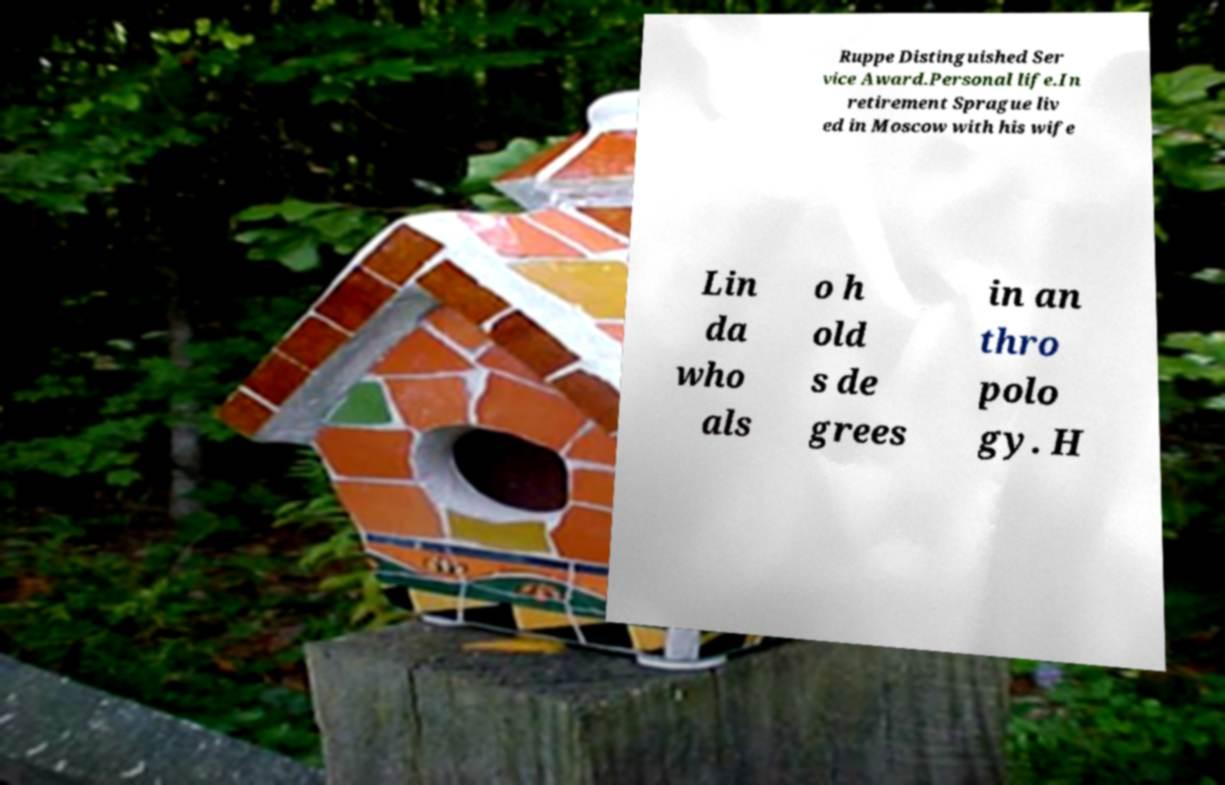Can you accurately transcribe the text from the provided image for me? Ruppe Distinguished Ser vice Award.Personal life.In retirement Sprague liv ed in Moscow with his wife Lin da who als o h old s de grees in an thro polo gy. H 